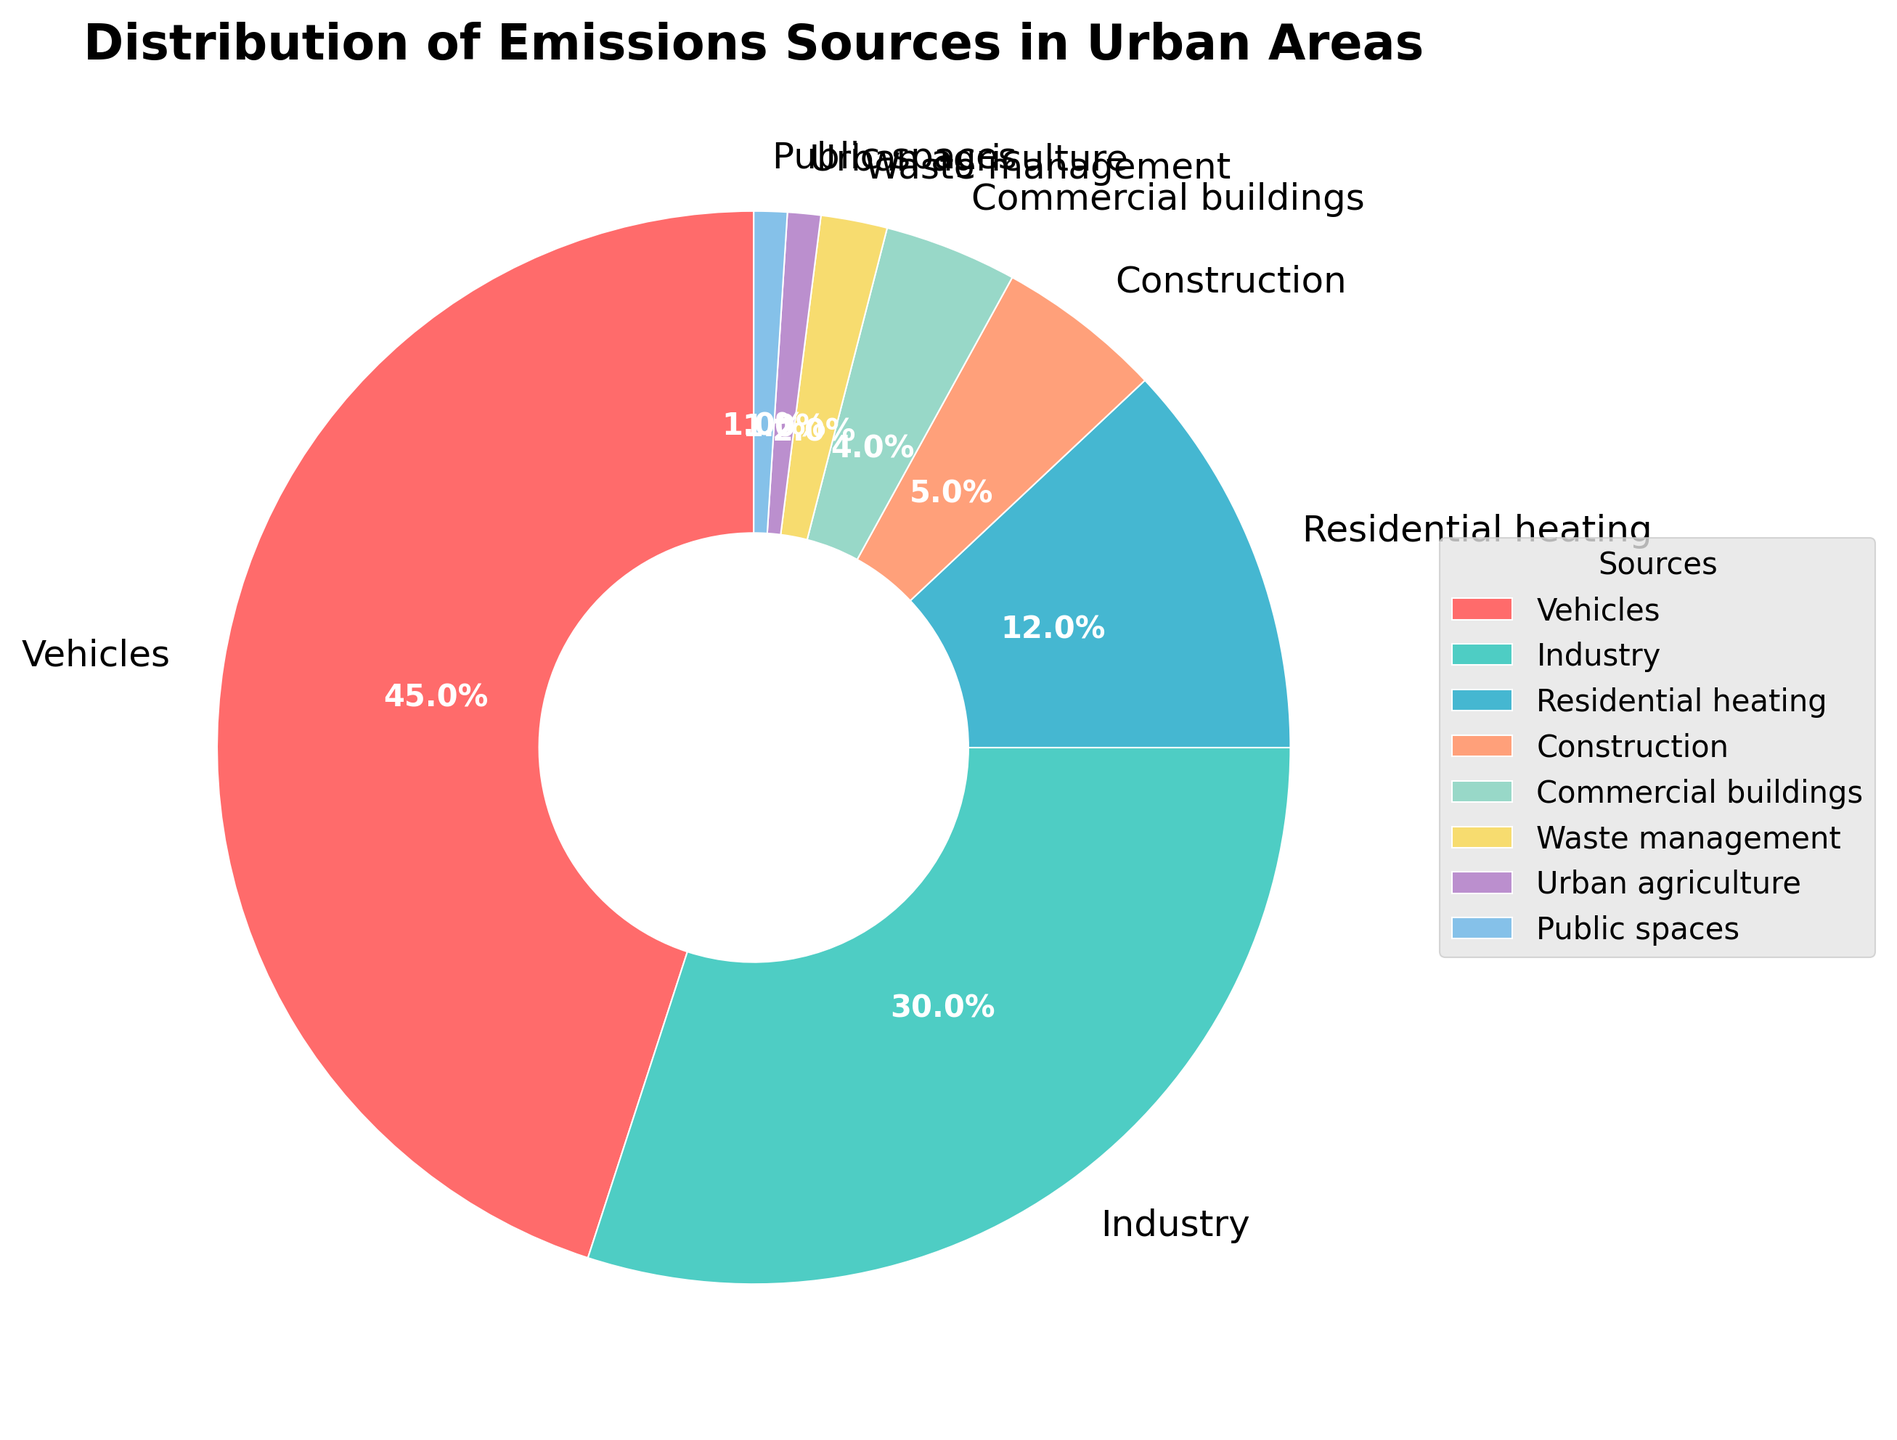Which emission source has the highest percentage? The section labeled "Vehicles" represents the largest portion of the pie chart, indicating its percentage is the highest among all sources.
Answer: Vehicles What is the combined percentage of emissions from Industry and Commercial buildings? The percentage for Industry is 30%, and for Commercial buildings, it is 4%. Adding these together gives 30% + 4% = 34%.
Answer: 34% Which category contributes less to emissions: Residential heating or Public spaces? The percentage for Residential heating is 12%, whereas Public spaces contribute 1%. Since 1% is less than 12%, Public spaces contribute less.
Answer: Public spaces What is the approximate difference in percentage between Vehicles and Industry emissions? Vehicles contribute 45%, while Industry contributes 30%. The difference is 45% - 30% = 15%.
Answer: 15% What is the total percentage of emissions from sources other than Vehicles? Subtract the Vehicles' percentage from 100%: 100% - 45% = 55%.
Answer: 55% How does the percentage of emissions from Waste management compare to that from Urban agriculture? Waste management contributes 2%, and Urban agriculture contributes 1%. Since 2% is greater than 1%, Waste management has a higher percentage.
Answer: Waste management Which emission source is represented by the pink color in the pie chart? By examining the colors used in the chart, the pink color corresponds to the "Vehicles" category.
Answer: Vehicles What percentage of emissions come from sources excluding Industry and Vehicles? Add up the percentages of all sources except Industry and Vehicles: 12% (Residential heating) + 5% (Construction) + 4% (Commercial buildings) + 2% (Waste management) + 1% (Urban agriculture) + 1% (Public spaces) = 25%.
Answer: 25% What is the ratio of emissions from Residential heating to Construction? Residential heating contributes 12%, and Construction contributes 5%. The ratio is 12:5.
Answer: 12:5 